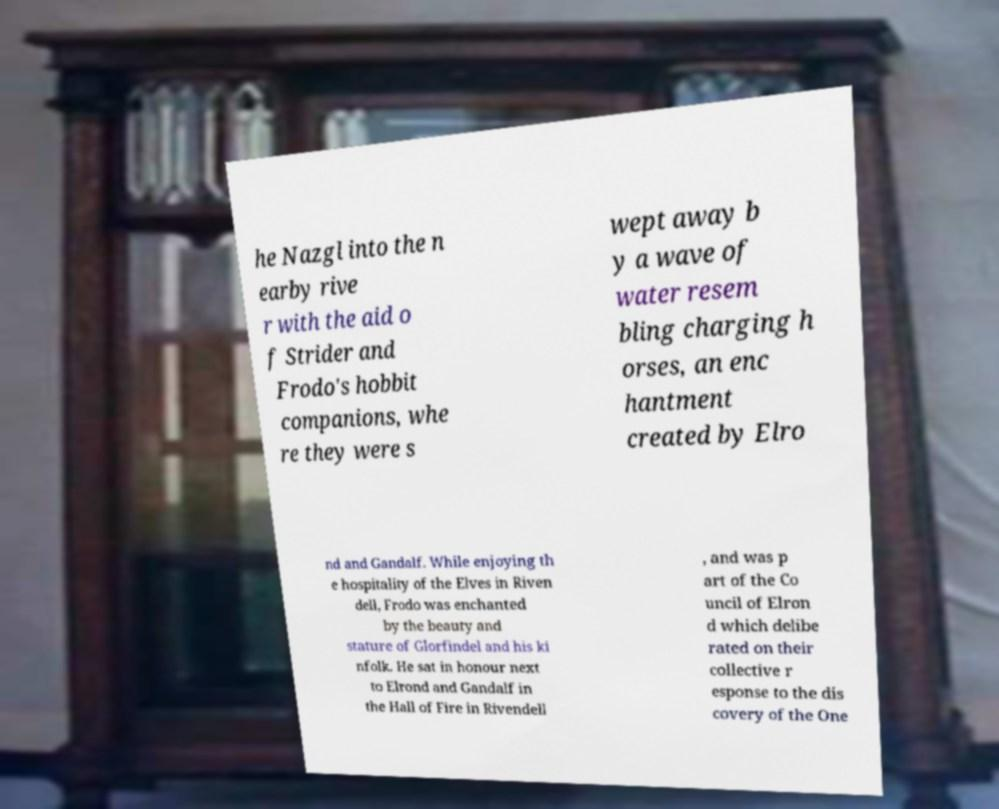Could you extract and type out the text from this image? he Nazgl into the n earby rive r with the aid o f Strider and Frodo's hobbit companions, whe re they were s wept away b y a wave of water resem bling charging h orses, an enc hantment created by Elro nd and Gandalf. While enjoying th e hospitality of the Elves in Riven dell, Frodo was enchanted by the beauty and stature of Glorfindel and his ki nfolk. He sat in honour next to Elrond and Gandalf in the Hall of Fire in Rivendell , and was p art of the Co uncil of Elron d which delibe rated on their collective r esponse to the dis covery of the One 